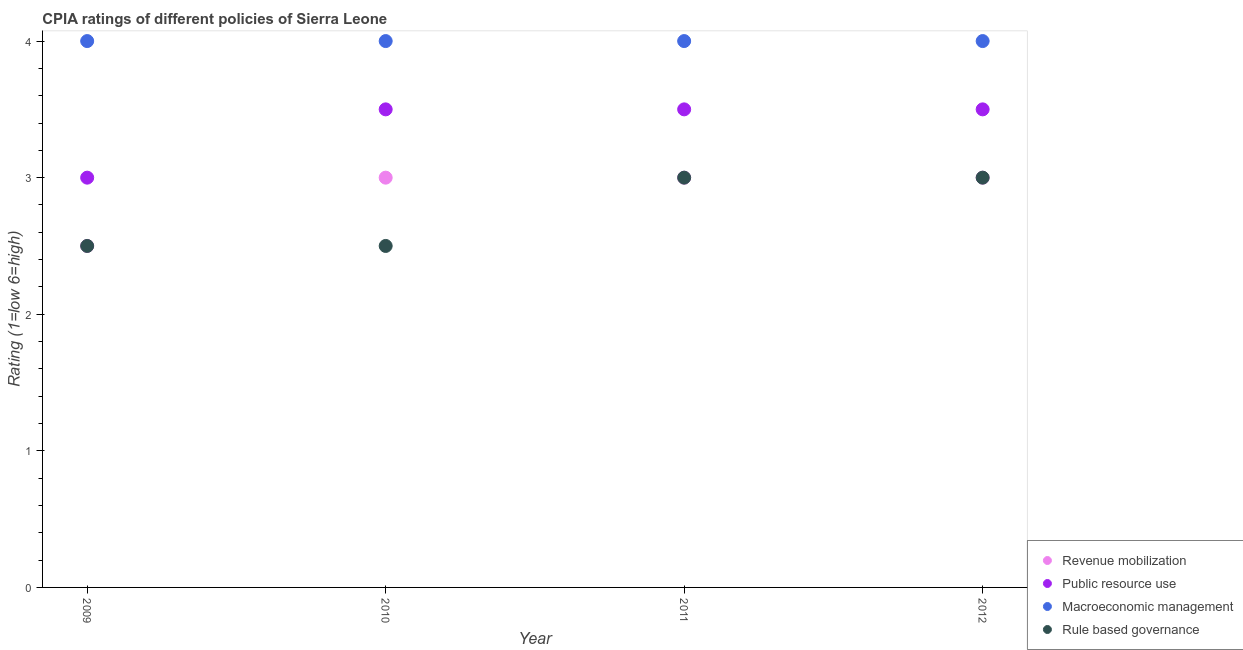How many different coloured dotlines are there?
Give a very brief answer. 4. What is the cpia rating of macroeconomic management in 2011?
Offer a very short reply. 4. Across all years, what is the maximum cpia rating of rule based governance?
Keep it short and to the point. 3. Across all years, what is the minimum cpia rating of revenue mobilization?
Keep it short and to the point. 2.5. What is the total cpia rating of rule based governance in the graph?
Offer a very short reply. 11. What is the average cpia rating of rule based governance per year?
Ensure brevity in your answer.  2.75. In the year 2009, what is the difference between the cpia rating of rule based governance and cpia rating of revenue mobilization?
Offer a very short reply. 0. In how many years, is the cpia rating of revenue mobilization greater than 3.2?
Offer a very short reply. 0. Is the cpia rating of public resource use in 2010 less than that in 2011?
Your answer should be compact. No. What is the difference between the highest and the lowest cpia rating of public resource use?
Your response must be concise. 0.5. In how many years, is the cpia rating of rule based governance greater than the average cpia rating of rule based governance taken over all years?
Offer a very short reply. 2. Is the sum of the cpia rating of macroeconomic management in 2009 and 2011 greater than the maximum cpia rating of revenue mobilization across all years?
Your answer should be compact. Yes. Is it the case that in every year, the sum of the cpia rating of macroeconomic management and cpia rating of revenue mobilization is greater than the sum of cpia rating of public resource use and cpia rating of rule based governance?
Make the answer very short. Yes. Is it the case that in every year, the sum of the cpia rating of revenue mobilization and cpia rating of public resource use is greater than the cpia rating of macroeconomic management?
Offer a terse response. Yes. Is the cpia rating of rule based governance strictly greater than the cpia rating of revenue mobilization over the years?
Ensure brevity in your answer.  No. Is the cpia rating of public resource use strictly less than the cpia rating of macroeconomic management over the years?
Provide a short and direct response. Yes. How many years are there in the graph?
Your answer should be very brief. 4. Does the graph contain any zero values?
Your answer should be very brief. No. Does the graph contain grids?
Your response must be concise. No. How many legend labels are there?
Ensure brevity in your answer.  4. What is the title of the graph?
Offer a very short reply. CPIA ratings of different policies of Sierra Leone. What is the Rating (1=low 6=high) of Rule based governance in 2009?
Make the answer very short. 2.5. What is the Rating (1=low 6=high) in Revenue mobilization in 2010?
Offer a terse response. 3. What is the Rating (1=low 6=high) of Public resource use in 2010?
Your answer should be very brief. 3.5. What is the Rating (1=low 6=high) of Macroeconomic management in 2010?
Your answer should be very brief. 4. What is the Rating (1=low 6=high) of Macroeconomic management in 2011?
Your response must be concise. 4. What is the Rating (1=low 6=high) in Rule based governance in 2011?
Keep it short and to the point. 3. What is the Rating (1=low 6=high) in Public resource use in 2012?
Offer a very short reply. 3.5. What is the Rating (1=low 6=high) in Rule based governance in 2012?
Your answer should be very brief. 3. Across all years, what is the maximum Rating (1=low 6=high) of Revenue mobilization?
Keep it short and to the point. 3. Across all years, what is the maximum Rating (1=low 6=high) of Public resource use?
Your answer should be very brief. 3.5. Across all years, what is the maximum Rating (1=low 6=high) in Rule based governance?
Make the answer very short. 3. Across all years, what is the minimum Rating (1=low 6=high) of Macroeconomic management?
Offer a very short reply. 4. What is the total Rating (1=low 6=high) in Macroeconomic management in the graph?
Your answer should be compact. 16. What is the difference between the Rating (1=low 6=high) of Revenue mobilization in 2009 and that in 2010?
Ensure brevity in your answer.  -0.5. What is the difference between the Rating (1=low 6=high) in Macroeconomic management in 2009 and that in 2010?
Offer a very short reply. 0. What is the difference between the Rating (1=low 6=high) in Revenue mobilization in 2009 and that in 2011?
Your answer should be compact. -0.5. What is the difference between the Rating (1=low 6=high) of Public resource use in 2009 and that in 2011?
Your response must be concise. -0.5. What is the difference between the Rating (1=low 6=high) in Macroeconomic management in 2009 and that in 2011?
Give a very brief answer. 0. What is the difference between the Rating (1=low 6=high) of Rule based governance in 2009 and that in 2011?
Offer a terse response. -0.5. What is the difference between the Rating (1=low 6=high) of Revenue mobilization in 2009 and that in 2012?
Ensure brevity in your answer.  -0.5. What is the difference between the Rating (1=low 6=high) in Public resource use in 2009 and that in 2012?
Offer a terse response. -0.5. What is the difference between the Rating (1=low 6=high) in Rule based governance in 2009 and that in 2012?
Make the answer very short. -0.5. What is the difference between the Rating (1=low 6=high) of Public resource use in 2010 and that in 2011?
Ensure brevity in your answer.  0. What is the difference between the Rating (1=low 6=high) in Macroeconomic management in 2010 and that in 2011?
Your response must be concise. 0. What is the difference between the Rating (1=low 6=high) of Macroeconomic management in 2010 and that in 2012?
Your answer should be compact. 0. What is the difference between the Rating (1=low 6=high) in Revenue mobilization in 2011 and that in 2012?
Make the answer very short. 0. What is the difference between the Rating (1=low 6=high) of Public resource use in 2011 and that in 2012?
Your answer should be compact. 0. What is the difference between the Rating (1=low 6=high) in Macroeconomic management in 2011 and that in 2012?
Give a very brief answer. 0. What is the difference between the Rating (1=low 6=high) of Rule based governance in 2011 and that in 2012?
Offer a very short reply. 0. What is the difference between the Rating (1=low 6=high) in Revenue mobilization in 2009 and the Rating (1=low 6=high) in Public resource use in 2010?
Your response must be concise. -1. What is the difference between the Rating (1=low 6=high) of Revenue mobilization in 2009 and the Rating (1=low 6=high) of Macroeconomic management in 2010?
Offer a very short reply. -1.5. What is the difference between the Rating (1=low 6=high) in Public resource use in 2009 and the Rating (1=low 6=high) in Macroeconomic management in 2010?
Your answer should be very brief. -1. What is the difference between the Rating (1=low 6=high) of Macroeconomic management in 2009 and the Rating (1=low 6=high) of Rule based governance in 2010?
Ensure brevity in your answer.  1.5. What is the difference between the Rating (1=low 6=high) of Revenue mobilization in 2009 and the Rating (1=low 6=high) of Public resource use in 2011?
Your answer should be compact. -1. What is the difference between the Rating (1=low 6=high) of Revenue mobilization in 2009 and the Rating (1=low 6=high) of Rule based governance in 2011?
Give a very brief answer. -0.5. What is the difference between the Rating (1=low 6=high) of Public resource use in 2009 and the Rating (1=low 6=high) of Rule based governance in 2011?
Provide a short and direct response. 0. What is the difference between the Rating (1=low 6=high) of Revenue mobilization in 2009 and the Rating (1=low 6=high) of Public resource use in 2012?
Offer a very short reply. -1. What is the difference between the Rating (1=low 6=high) in Revenue mobilization in 2009 and the Rating (1=low 6=high) in Macroeconomic management in 2012?
Your answer should be compact. -1.5. What is the difference between the Rating (1=low 6=high) in Public resource use in 2009 and the Rating (1=low 6=high) in Macroeconomic management in 2012?
Your answer should be compact. -1. What is the difference between the Rating (1=low 6=high) in Public resource use in 2009 and the Rating (1=low 6=high) in Rule based governance in 2012?
Provide a short and direct response. 0. What is the difference between the Rating (1=low 6=high) in Revenue mobilization in 2010 and the Rating (1=low 6=high) in Rule based governance in 2011?
Give a very brief answer. 0. What is the difference between the Rating (1=low 6=high) in Revenue mobilization in 2010 and the Rating (1=low 6=high) in Macroeconomic management in 2012?
Provide a short and direct response. -1. What is the difference between the Rating (1=low 6=high) of Revenue mobilization in 2010 and the Rating (1=low 6=high) of Rule based governance in 2012?
Ensure brevity in your answer.  0. What is the difference between the Rating (1=low 6=high) of Public resource use in 2010 and the Rating (1=low 6=high) of Macroeconomic management in 2012?
Your response must be concise. -0.5. What is the difference between the Rating (1=low 6=high) in Public resource use in 2010 and the Rating (1=low 6=high) in Rule based governance in 2012?
Provide a short and direct response. 0.5. What is the difference between the Rating (1=low 6=high) in Revenue mobilization in 2011 and the Rating (1=low 6=high) in Public resource use in 2012?
Offer a very short reply. -0.5. What is the difference between the Rating (1=low 6=high) of Public resource use in 2011 and the Rating (1=low 6=high) of Macroeconomic management in 2012?
Make the answer very short. -0.5. What is the difference between the Rating (1=low 6=high) of Public resource use in 2011 and the Rating (1=low 6=high) of Rule based governance in 2012?
Your answer should be compact. 0.5. What is the average Rating (1=low 6=high) in Revenue mobilization per year?
Your answer should be very brief. 2.88. What is the average Rating (1=low 6=high) in Public resource use per year?
Ensure brevity in your answer.  3.38. What is the average Rating (1=low 6=high) of Macroeconomic management per year?
Offer a terse response. 4. What is the average Rating (1=low 6=high) of Rule based governance per year?
Keep it short and to the point. 2.75. In the year 2009, what is the difference between the Rating (1=low 6=high) in Revenue mobilization and Rating (1=low 6=high) in Public resource use?
Your answer should be compact. -0.5. In the year 2009, what is the difference between the Rating (1=low 6=high) in Public resource use and Rating (1=low 6=high) in Rule based governance?
Provide a short and direct response. 0.5. In the year 2010, what is the difference between the Rating (1=low 6=high) of Revenue mobilization and Rating (1=low 6=high) of Public resource use?
Offer a very short reply. -0.5. In the year 2010, what is the difference between the Rating (1=low 6=high) in Public resource use and Rating (1=low 6=high) in Macroeconomic management?
Your response must be concise. -0.5. In the year 2011, what is the difference between the Rating (1=low 6=high) in Revenue mobilization and Rating (1=low 6=high) in Public resource use?
Make the answer very short. -0.5. In the year 2011, what is the difference between the Rating (1=low 6=high) in Revenue mobilization and Rating (1=low 6=high) in Rule based governance?
Offer a terse response. 0. In the year 2011, what is the difference between the Rating (1=low 6=high) of Public resource use and Rating (1=low 6=high) of Rule based governance?
Your response must be concise. 0.5. In the year 2012, what is the difference between the Rating (1=low 6=high) of Revenue mobilization and Rating (1=low 6=high) of Public resource use?
Provide a short and direct response. -0.5. In the year 2012, what is the difference between the Rating (1=low 6=high) in Revenue mobilization and Rating (1=low 6=high) in Macroeconomic management?
Provide a succinct answer. -1. In the year 2012, what is the difference between the Rating (1=low 6=high) of Revenue mobilization and Rating (1=low 6=high) of Rule based governance?
Your response must be concise. 0. In the year 2012, what is the difference between the Rating (1=low 6=high) of Public resource use and Rating (1=low 6=high) of Rule based governance?
Offer a very short reply. 0.5. In the year 2012, what is the difference between the Rating (1=low 6=high) of Macroeconomic management and Rating (1=low 6=high) of Rule based governance?
Provide a succinct answer. 1. What is the ratio of the Rating (1=low 6=high) of Public resource use in 2009 to that in 2010?
Offer a very short reply. 0.86. What is the ratio of the Rating (1=low 6=high) of Macroeconomic management in 2009 to that in 2010?
Offer a terse response. 1. What is the ratio of the Rating (1=low 6=high) in Revenue mobilization in 2009 to that in 2011?
Keep it short and to the point. 0.83. What is the ratio of the Rating (1=low 6=high) of Public resource use in 2009 to that in 2011?
Give a very brief answer. 0.86. What is the ratio of the Rating (1=low 6=high) in Revenue mobilization in 2009 to that in 2012?
Offer a terse response. 0.83. What is the ratio of the Rating (1=low 6=high) of Macroeconomic management in 2009 to that in 2012?
Provide a succinct answer. 1. What is the ratio of the Rating (1=low 6=high) in Rule based governance in 2009 to that in 2012?
Offer a terse response. 0.83. What is the ratio of the Rating (1=low 6=high) of Revenue mobilization in 2010 to that in 2011?
Your response must be concise. 1. What is the ratio of the Rating (1=low 6=high) in Macroeconomic management in 2010 to that in 2011?
Provide a short and direct response. 1. What is the ratio of the Rating (1=low 6=high) of Rule based governance in 2010 to that in 2011?
Provide a succinct answer. 0.83. What is the ratio of the Rating (1=low 6=high) of Revenue mobilization in 2010 to that in 2012?
Make the answer very short. 1. What is the ratio of the Rating (1=low 6=high) of Public resource use in 2010 to that in 2012?
Offer a terse response. 1. What is the ratio of the Rating (1=low 6=high) of Macroeconomic management in 2011 to that in 2012?
Provide a short and direct response. 1. What is the difference between the highest and the second highest Rating (1=low 6=high) of Public resource use?
Provide a succinct answer. 0. 